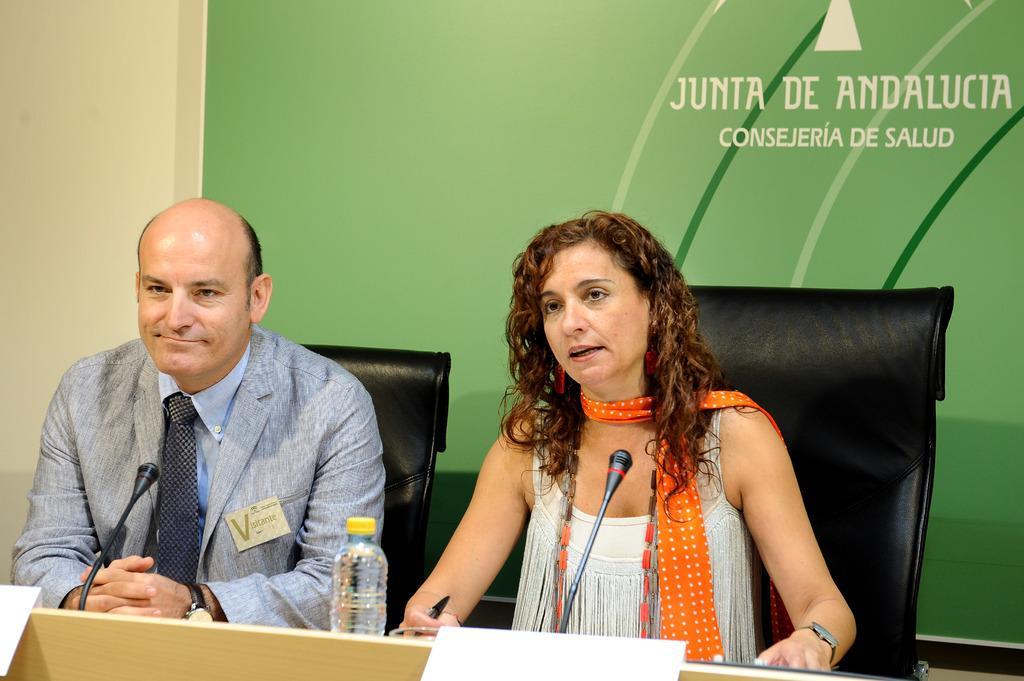Could you give a brief overview of what you see in this image? In this image there is a man and a woman sitting in chairs, in front of them on the table there are mice, a bottle of water, pen and papers, behind them there is a poster on the wall. 